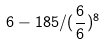<formula> <loc_0><loc_0><loc_500><loc_500>6 - 1 8 5 / ( \frac { 6 } { 6 } ) ^ { 8 }</formula> 